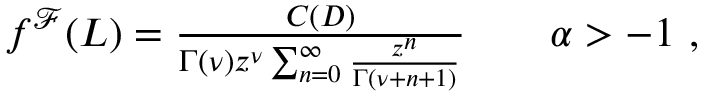<formula> <loc_0><loc_0><loc_500><loc_500>\begin{array} { r } { f ^ { \mathcal { F } } ( L ) = \frac { C ( D ) } { \Gamma ( \nu ) z ^ { \nu } \sum _ { n = 0 } ^ { \infty } \frac { z ^ { n } } { \Gamma ( \nu + n + 1 ) } } \quad \alpha > - 1 \ , } \end{array}</formula> 